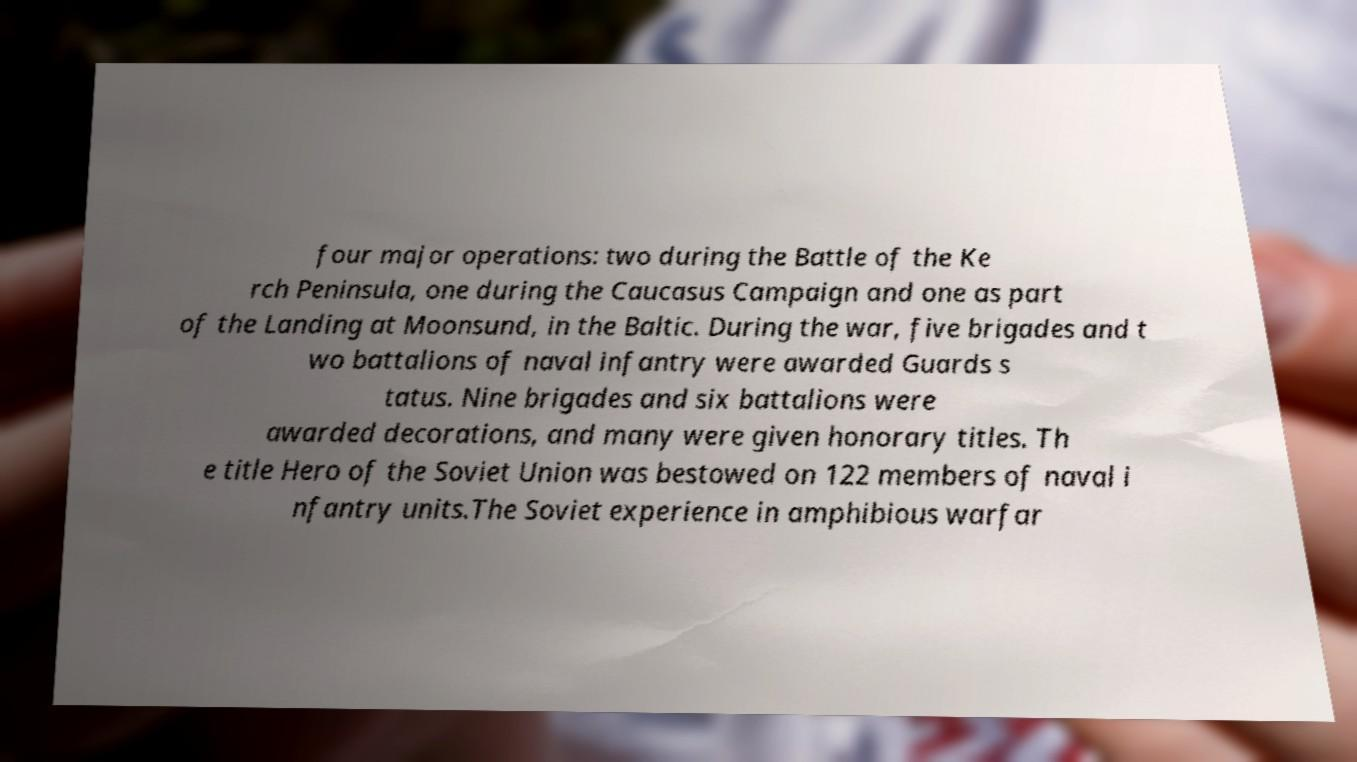Could you extract and type out the text from this image? four major operations: two during the Battle of the Ke rch Peninsula, one during the Caucasus Campaign and one as part of the Landing at Moonsund, in the Baltic. During the war, five brigades and t wo battalions of naval infantry were awarded Guards s tatus. Nine brigades and six battalions were awarded decorations, and many were given honorary titles. Th e title Hero of the Soviet Union was bestowed on 122 members of naval i nfantry units.The Soviet experience in amphibious warfar 